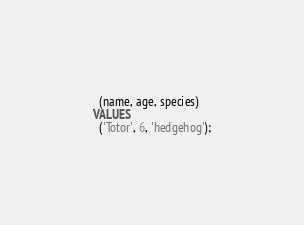<code> <loc_0><loc_0><loc_500><loc_500><_SQL_>  (name, age, species)
VALUES
  ('Totor', 6, 'hedgehog');
</code> 